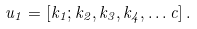Convert formula to latex. <formula><loc_0><loc_0><loc_500><loc_500>\ u _ { 1 } = [ k _ { 1 } ; k _ { 2 } , k _ { 3 } , k _ { 4 } , \dots c ] \, .</formula> 